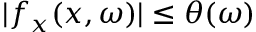<formula> <loc_0><loc_0><loc_500><loc_500>| f _ { x } ( x , \omega ) | \leq \theta ( \omega )</formula> 